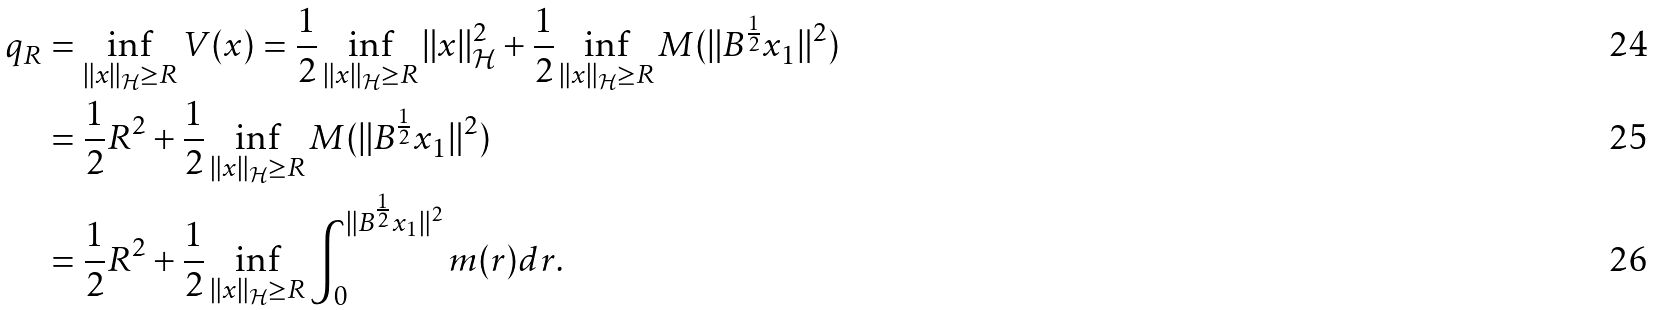<formula> <loc_0><loc_0><loc_500><loc_500>q _ { R } & = \inf _ { \| x \| _ { \mathcal { H } } \geq R } V ( x ) = \frac { 1 } { 2 } \inf _ { \| x \| _ { \mathcal { H } } \geq R } \| x \| _ { \mathcal { H } } ^ { 2 } + \frac { 1 } { 2 } \inf _ { \| x \| _ { \mathcal { H } } \geq R } M ( \| B ^ { \frac { 1 } { 2 } } x _ { 1 } \| ^ { 2 } ) \\ & = \frac { 1 } { 2 } R ^ { 2 } + \frac { 1 } { 2 } \inf _ { \| x \| _ { \mathcal { H } } \geq R } M ( \| B ^ { \frac { 1 } { 2 } } x _ { 1 } \| ^ { 2 } ) \\ & = \frac { 1 } { 2 } R ^ { 2 } + \frac { 1 } { 2 } \inf _ { \| x \| _ { \mathcal { H } } \geq R } \int _ { 0 } ^ { \| B ^ { \frac { 1 } { 2 } } x _ { 1 } \| ^ { 2 } } m ( r ) d r .</formula> 